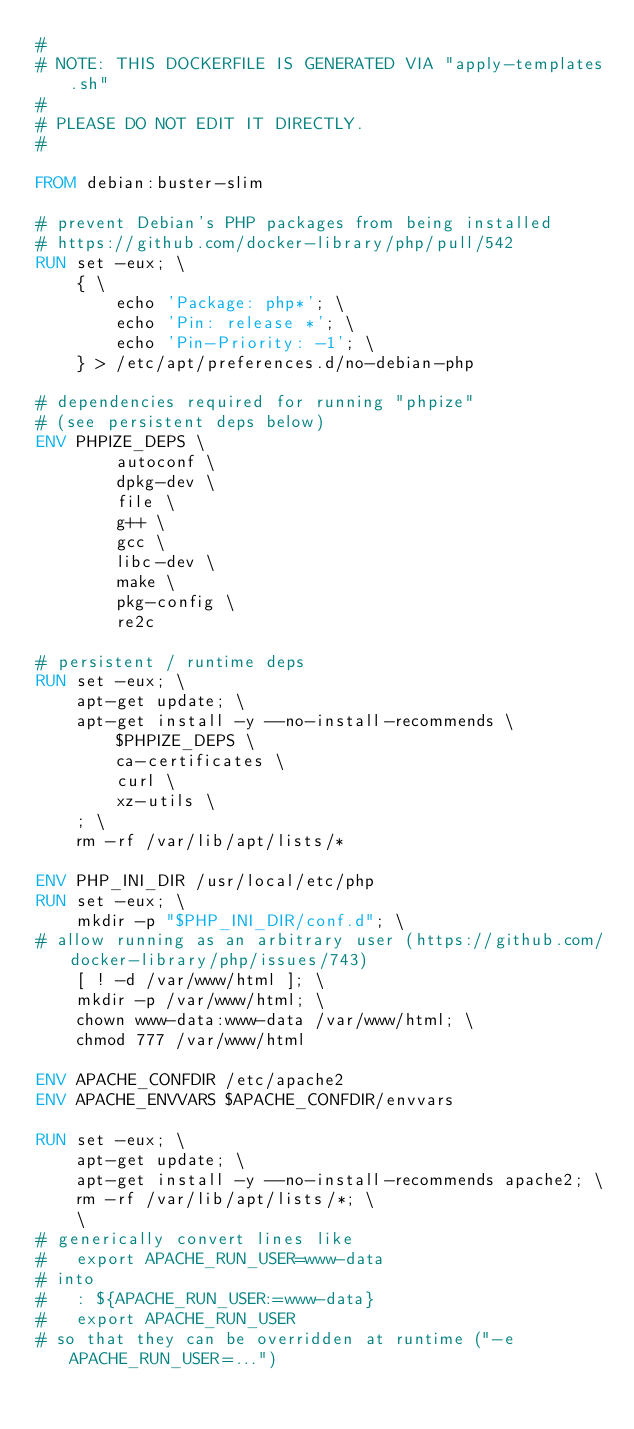<code> <loc_0><loc_0><loc_500><loc_500><_Dockerfile_>#
# NOTE: THIS DOCKERFILE IS GENERATED VIA "apply-templates.sh"
#
# PLEASE DO NOT EDIT IT DIRECTLY.
#

FROM debian:buster-slim

# prevent Debian's PHP packages from being installed
# https://github.com/docker-library/php/pull/542
RUN set -eux; \
	{ \
		echo 'Package: php*'; \
		echo 'Pin: release *'; \
		echo 'Pin-Priority: -1'; \
	} > /etc/apt/preferences.d/no-debian-php

# dependencies required for running "phpize"
# (see persistent deps below)
ENV PHPIZE_DEPS \
		autoconf \
		dpkg-dev \
		file \
		g++ \
		gcc \
		libc-dev \
		make \
		pkg-config \
		re2c

# persistent / runtime deps
RUN set -eux; \
	apt-get update; \
	apt-get install -y --no-install-recommends \
		$PHPIZE_DEPS \
		ca-certificates \
		curl \
		xz-utils \
	; \
	rm -rf /var/lib/apt/lists/*

ENV PHP_INI_DIR /usr/local/etc/php
RUN set -eux; \
	mkdir -p "$PHP_INI_DIR/conf.d"; \
# allow running as an arbitrary user (https://github.com/docker-library/php/issues/743)
	[ ! -d /var/www/html ]; \
	mkdir -p /var/www/html; \
	chown www-data:www-data /var/www/html; \
	chmod 777 /var/www/html

ENV APACHE_CONFDIR /etc/apache2
ENV APACHE_ENVVARS $APACHE_CONFDIR/envvars

RUN set -eux; \
	apt-get update; \
	apt-get install -y --no-install-recommends apache2; \
	rm -rf /var/lib/apt/lists/*; \
	\
# generically convert lines like
#   export APACHE_RUN_USER=www-data
# into
#   : ${APACHE_RUN_USER:=www-data}
#   export APACHE_RUN_USER
# so that they can be overridden at runtime ("-e APACHE_RUN_USER=...")</code> 